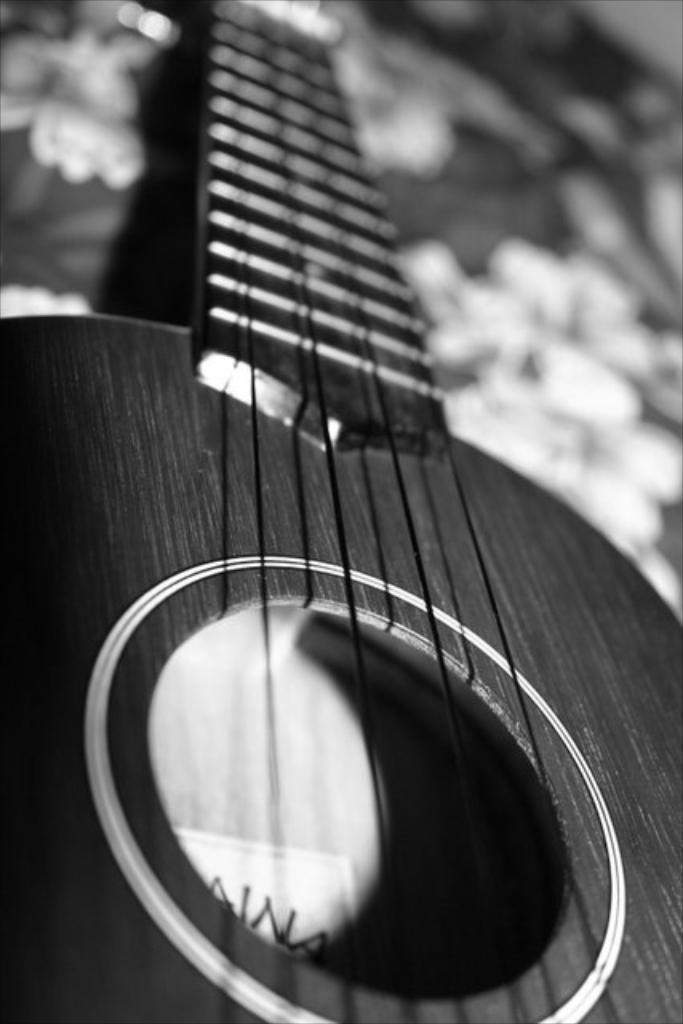What type of object is the main subject of the image? The main subject of the image is a musical instrument. What type of shade is covering the scene in the image? There is no shade or scene present in the image; it only contains a musical instrument. 